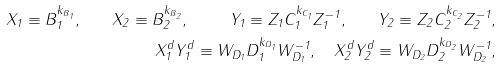Convert formula to latex. <formula><loc_0><loc_0><loc_500><loc_500>X _ { 1 } \equiv B _ { 1 } ^ { k _ { B _ { 1 } } } , \quad X _ { 2 } \equiv B _ { 2 } ^ { k _ { B _ { 2 } } } , \quad \ Y _ { 1 } \equiv Z _ { 1 } C _ { 1 } ^ { k _ { C _ { 1 } } } Z _ { 1 } ^ { - 1 } , \quad Y _ { 2 } \equiv Z _ { 2 } C _ { 2 } ^ { k _ { C _ { 2 } } } Z _ { 2 } ^ { - 1 } , \\ X _ { 1 } ^ { d } Y _ { 1 } ^ { d } \equiv W _ { D _ { 1 } } D _ { 1 } ^ { k _ { D _ { 1 } } } W _ { D _ { 1 } } ^ { - 1 } , \quad X _ { 2 } ^ { d } Y _ { 2 } ^ { d } \equiv W _ { D _ { 2 } } D _ { 2 } ^ { k _ { D _ { 2 } } } W _ { D _ { 2 } } ^ { - 1 } ,</formula> 